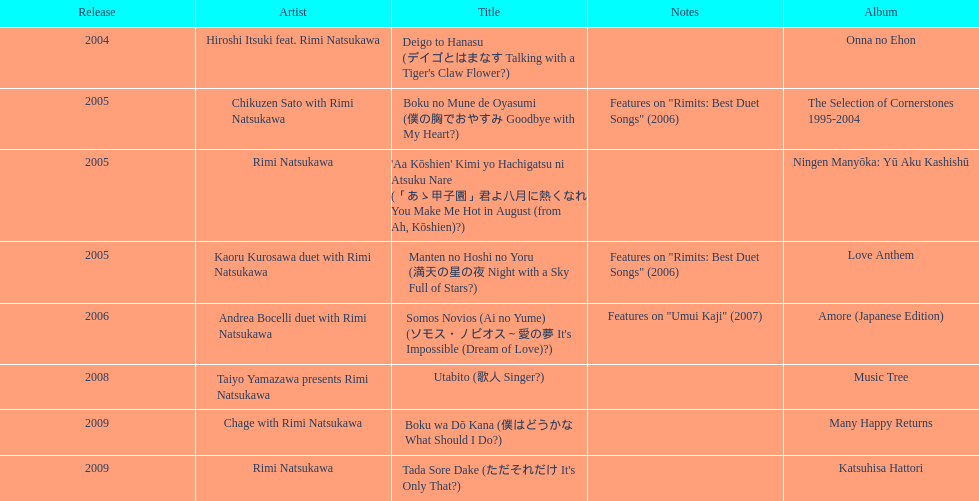How many titles are attributed to just one artist? 2. 